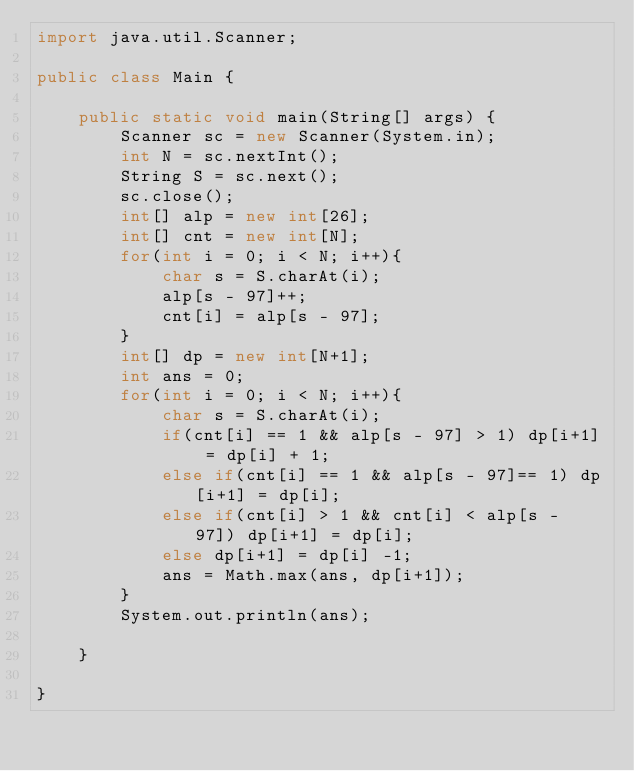Convert code to text. <code><loc_0><loc_0><loc_500><loc_500><_Java_>import java.util.Scanner;

public class Main {

    public static void main(String[] args) {
        Scanner sc = new Scanner(System.in);
        int N = sc.nextInt();
        String S = sc.next();
        sc.close();
        int[] alp = new int[26];
        int[] cnt = new int[N];
        for(int i = 0; i < N; i++){
            char s = S.charAt(i);
            alp[s - 97]++;
            cnt[i] = alp[s - 97];
        }
        int[] dp = new int[N+1];
        int ans = 0;
        for(int i = 0; i < N; i++){
            char s = S.charAt(i);
            if(cnt[i] == 1 && alp[s - 97] > 1) dp[i+1] = dp[i] + 1;
            else if(cnt[i] == 1 && alp[s - 97]== 1) dp[i+1] = dp[i];
            else if(cnt[i] > 1 && cnt[i] < alp[s - 97]) dp[i+1] = dp[i];
            else dp[i+1] = dp[i] -1;
            ans = Math.max(ans, dp[i+1]);
        }
        System.out.println(ans);

    }

}
</code> 